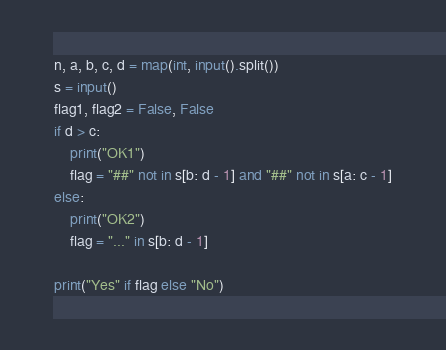Convert code to text. <code><loc_0><loc_0><loc_500><loc_500><_Python_>n, a, b, c, d = map(int, input().split())
s = input()
flag1, flag2 = False, False
if d > c:
    print("OK1")
    flag = "##" not in s[b: d - 1] and "##" not in s[a: c - 1]
else:
    print("OK2")
    flag = "..." in s[b: d - 1]

print("Yes" if flag else "No")</code> 